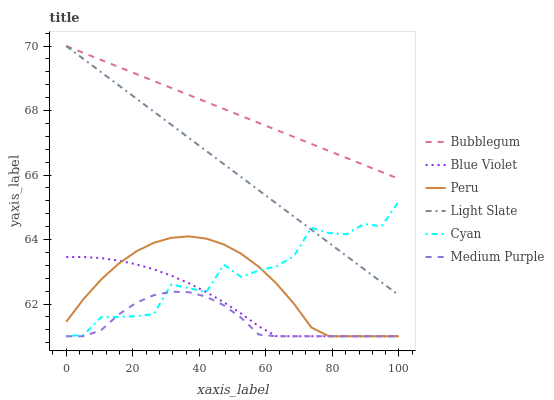Does Bubblegum have the minimum area under the curve?
Answer yes or no. No. Does Medium Purple have the maximum area under the curve?
Answer yes or no. No. Is Medium Purple the smoothest?
Answer yes or no. No. Is Medium Purple the roughest?
Answer yes or no. No. Does Bubblegum have the lowest value?
Answer yes or no. No. Does Medium Purple have the highest value?
Answer yes or no. No. Is Peru less than Bubblegum?
Answer yes or no. Yes. Is Bubblegum greater than Medium Purple?
Answer yes or no. Yes. Does Peru intersect Bubblegum?
Answer yes or no. No. 